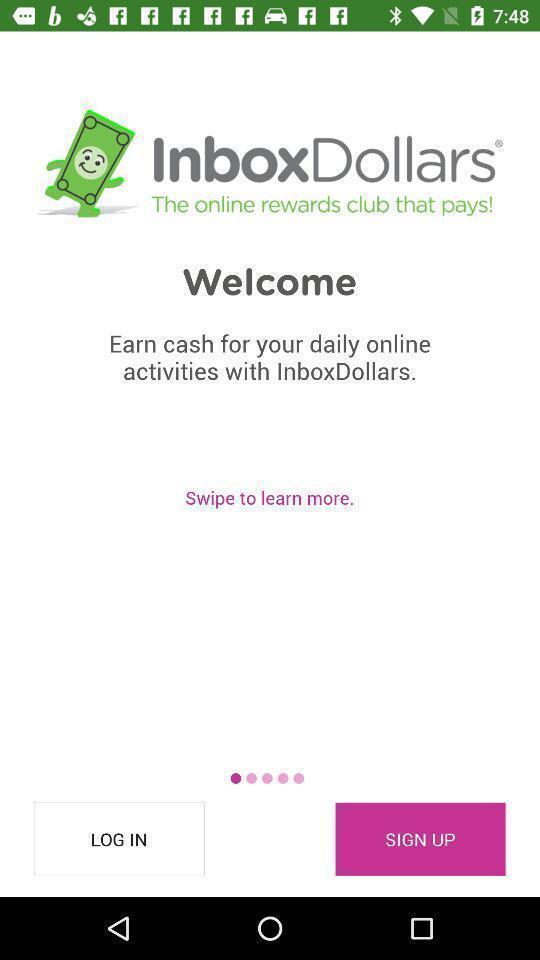Describe the key features of this screenshot. Welcome page with different options in payment application. 